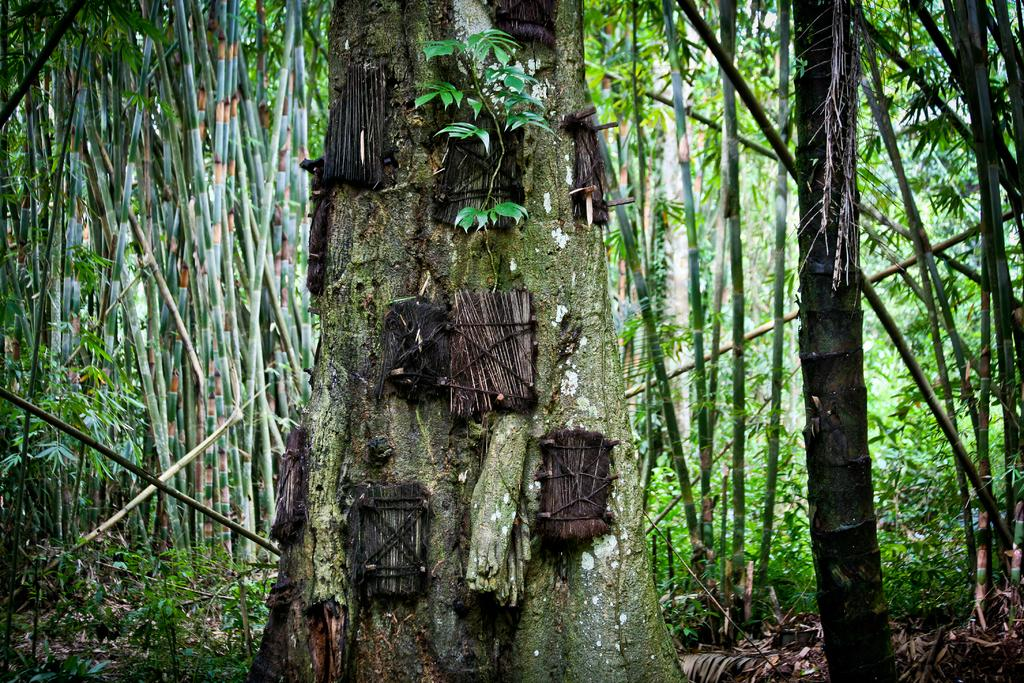What type of vegetation can be seen in the image? There are trees and plants in the image. What is the condition of the leaves on the trees and plants? Dried leaves are present in the image. What type of jeans can be seen hanging on the tree in the image? There are no jeans present in the image; it only features trees, plants, and dried leaves. 